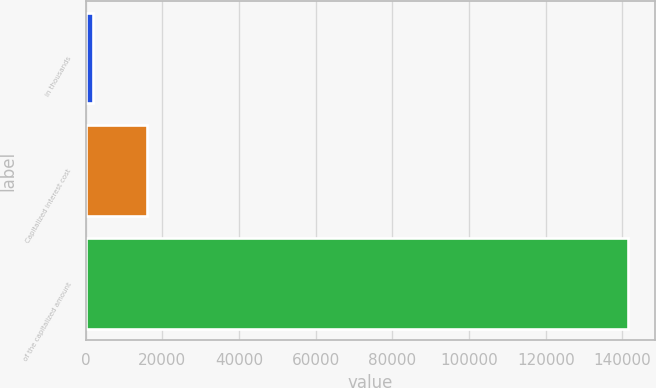Convert chart. <chart><loc_0><loc_0><loc_500><loc_500><bar_chart><fcel>in thousands<fcel>Capitalized interest cost<fcel>of the capitalized amount<nl><fcel>2016<fcel>15968.8<fcel>141544<nl></chart> 